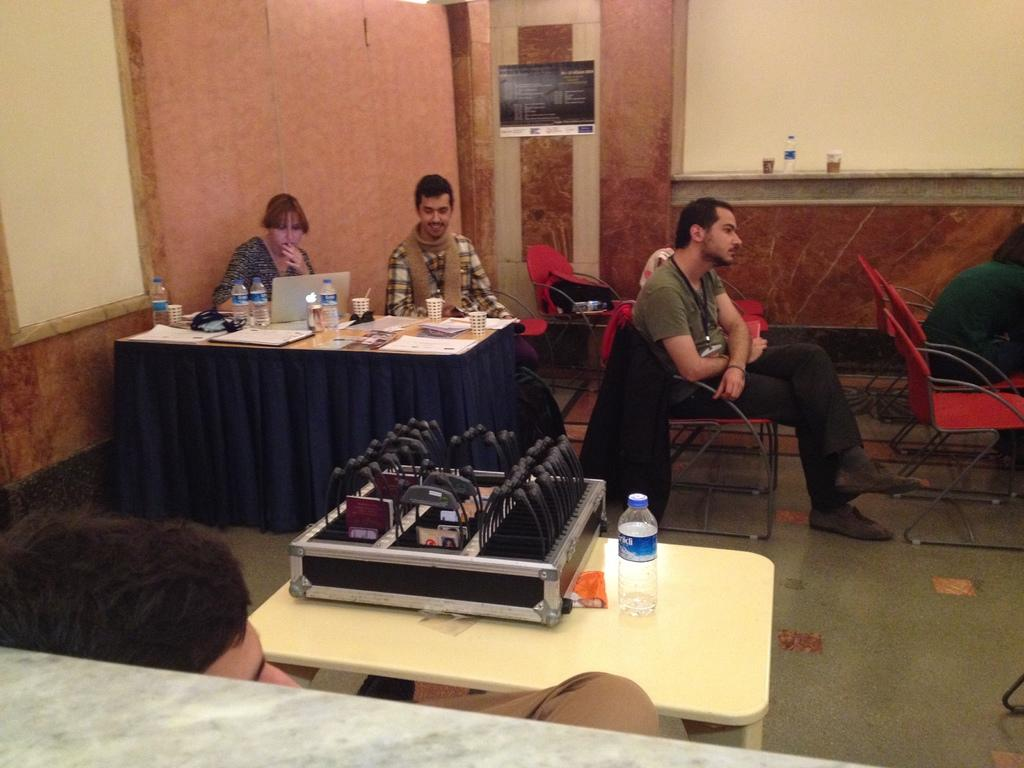What type of furniture is visible in the image? There are chairs and tables in the image. What objects are placed on the tables? Laptops, water bottles, and papers are placed on the tables. What can be seen in the background of the image? There is a wall in the background of the image. What type of song is being played by the mice in the image? There are no mice present in the image, so there is no song being played by them. 